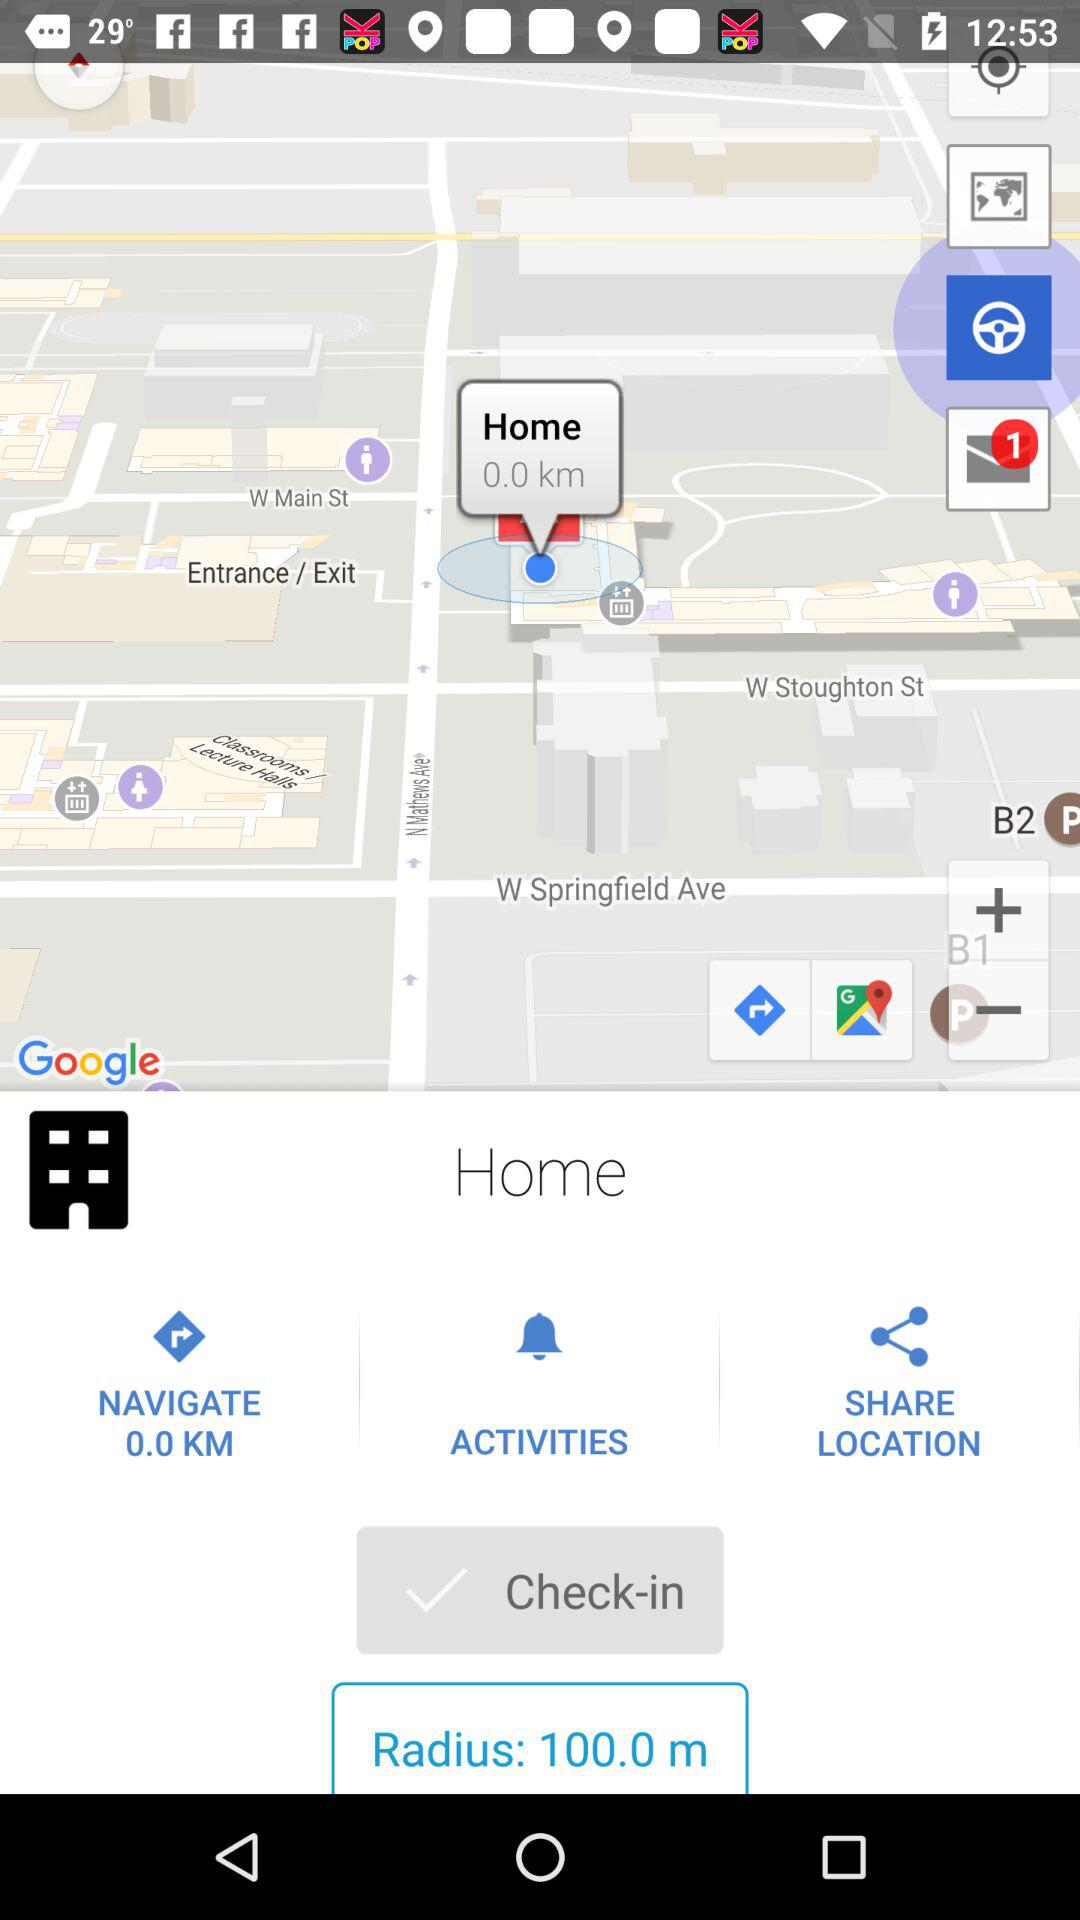How many meters is the radius of the circle?
Answer the question using a single word or phrase. 100.0 m 